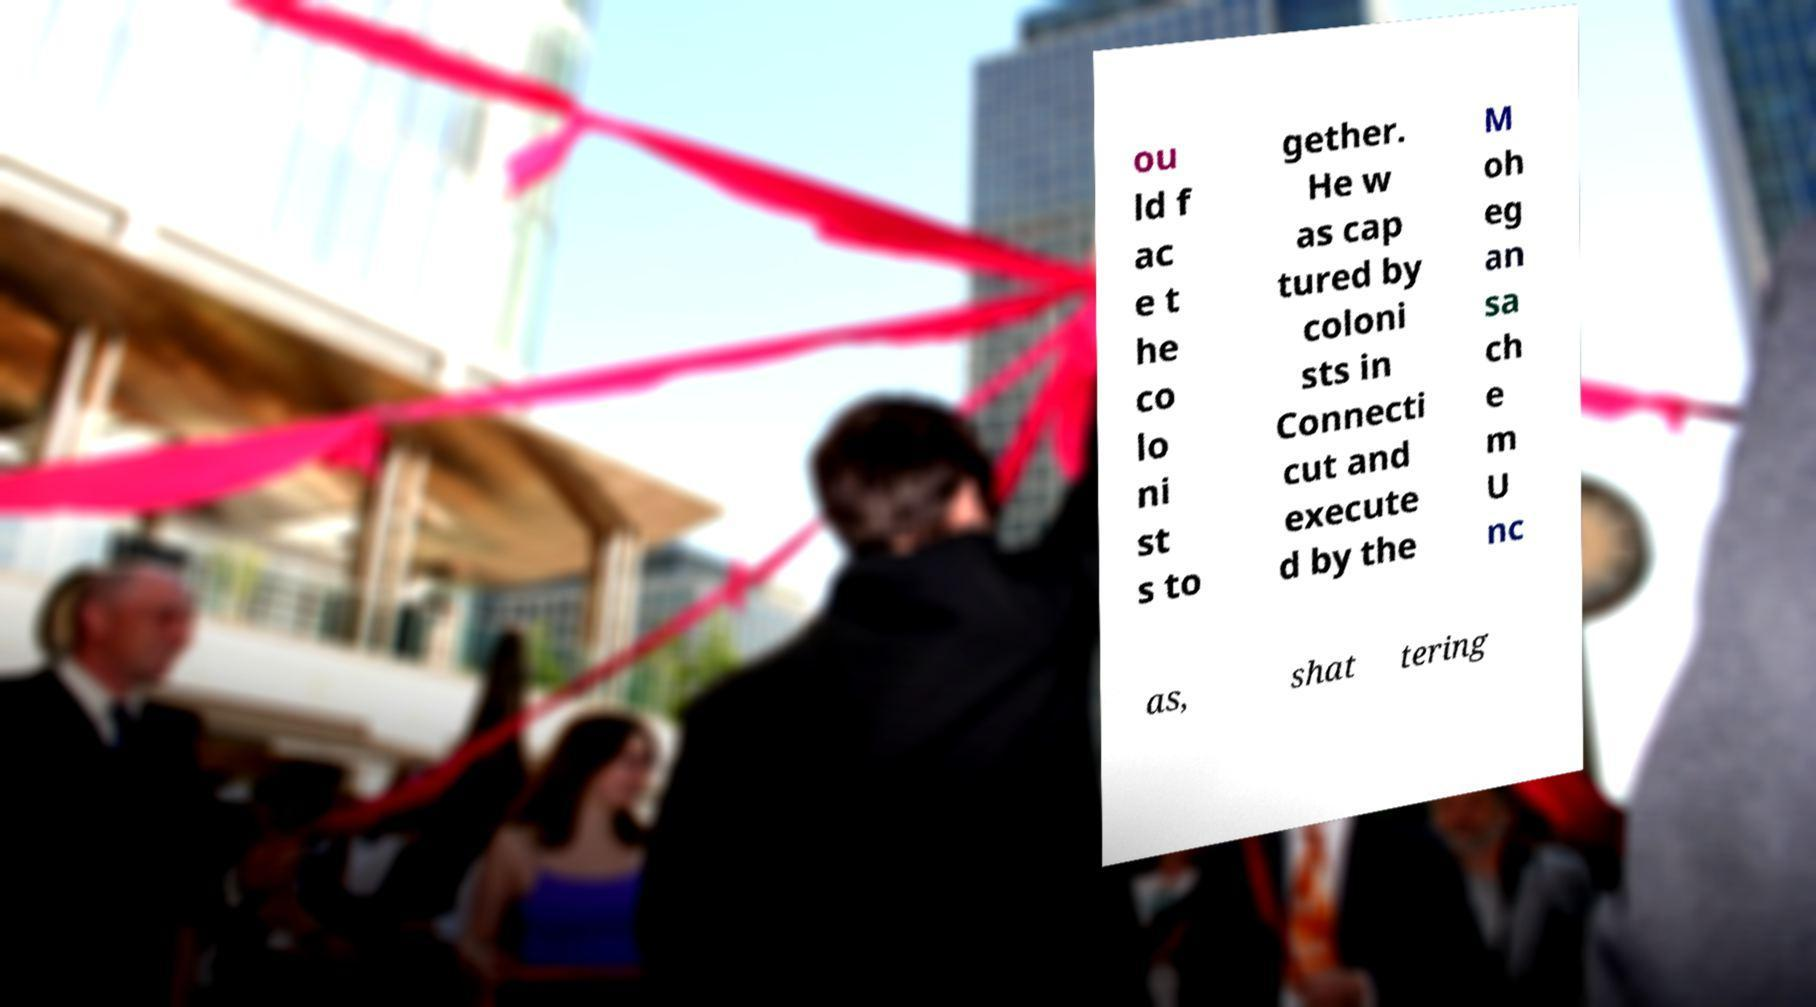Can you read and provide the text displayed in the image?This photo seems to have some interesting text. Can you extract and type it out for me? ou ld f ac e t he co lo ni st s to gether. He w as cap tured by coloni sts in Connecti cut and execute d by the M oh eg an sa ch e m U nc as, shat tering 